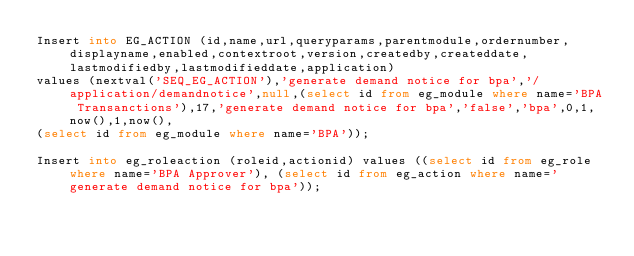<code> <loc_0><loc_0><loc_500><loc_500><_SQL_>Insert into EG_ACTION (id,name,url,queryparams,parentmodule,ordernumber,displayname,enabled,contextroot,version,createdby,createddate,lastmodifiedby,lastmodifieddate,application) 
values (nextval('SEQ_EG_ACTION'),'generate demand notice for bpa','/application/demandnotice',null,(select id from eg_module where name='BPA Transanctions'),17,'generate demand notice for bpa','false','bpa',0,1,now(),1,now(),
(select id from eg_module where name='BPA'));

Insert into eg_roleaction (roleid,actionid) values ((select id from eg_role where name='BPA Approver'), (select id from eg_action where name='generate demand notice for bpa'));</code> 